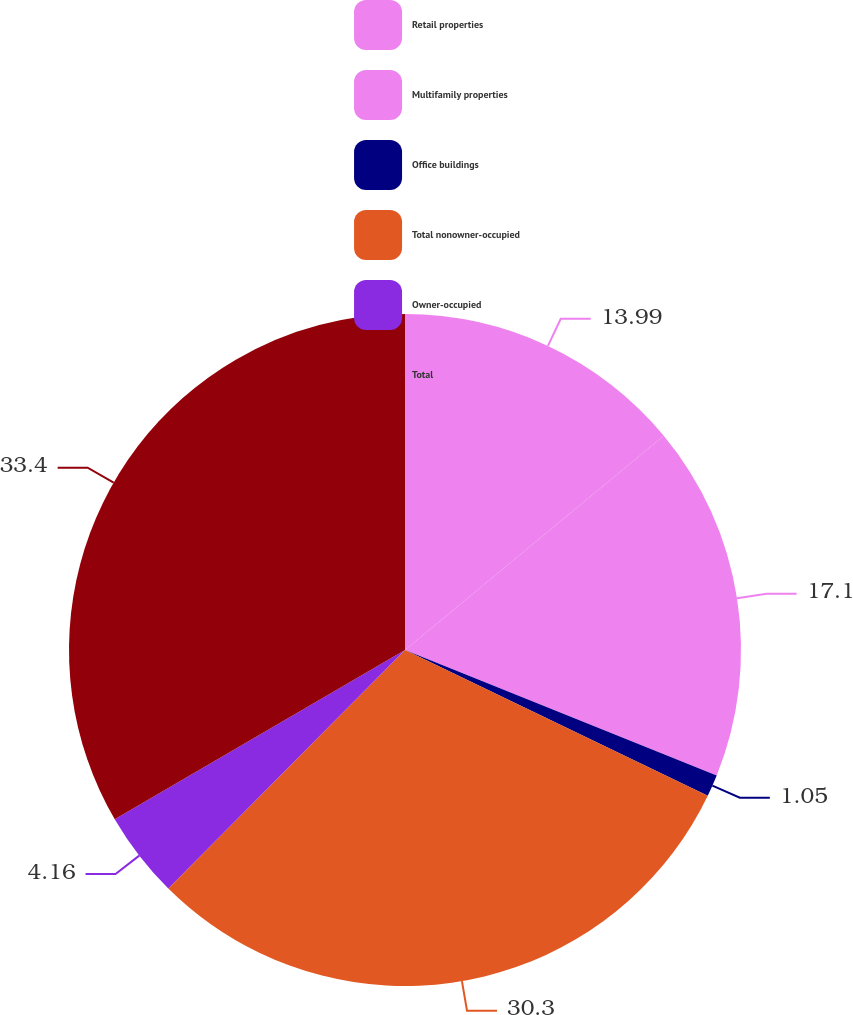Convert chart. <chart><loc_0><loc_0><loc_500><loc_500><pie_chart><fcel>Retail properties<fcel>Multifamily properties<fcel>Office buildings<fcel>Total nonowner-occupied<fcel>Owner-occupied<fcel>Total<nl><fcel>13.99%<fcel>17.1%<fcel>1.05%<fcel>30.3%<fcel>4.16%<fcel>33.4%<nl></chart> 